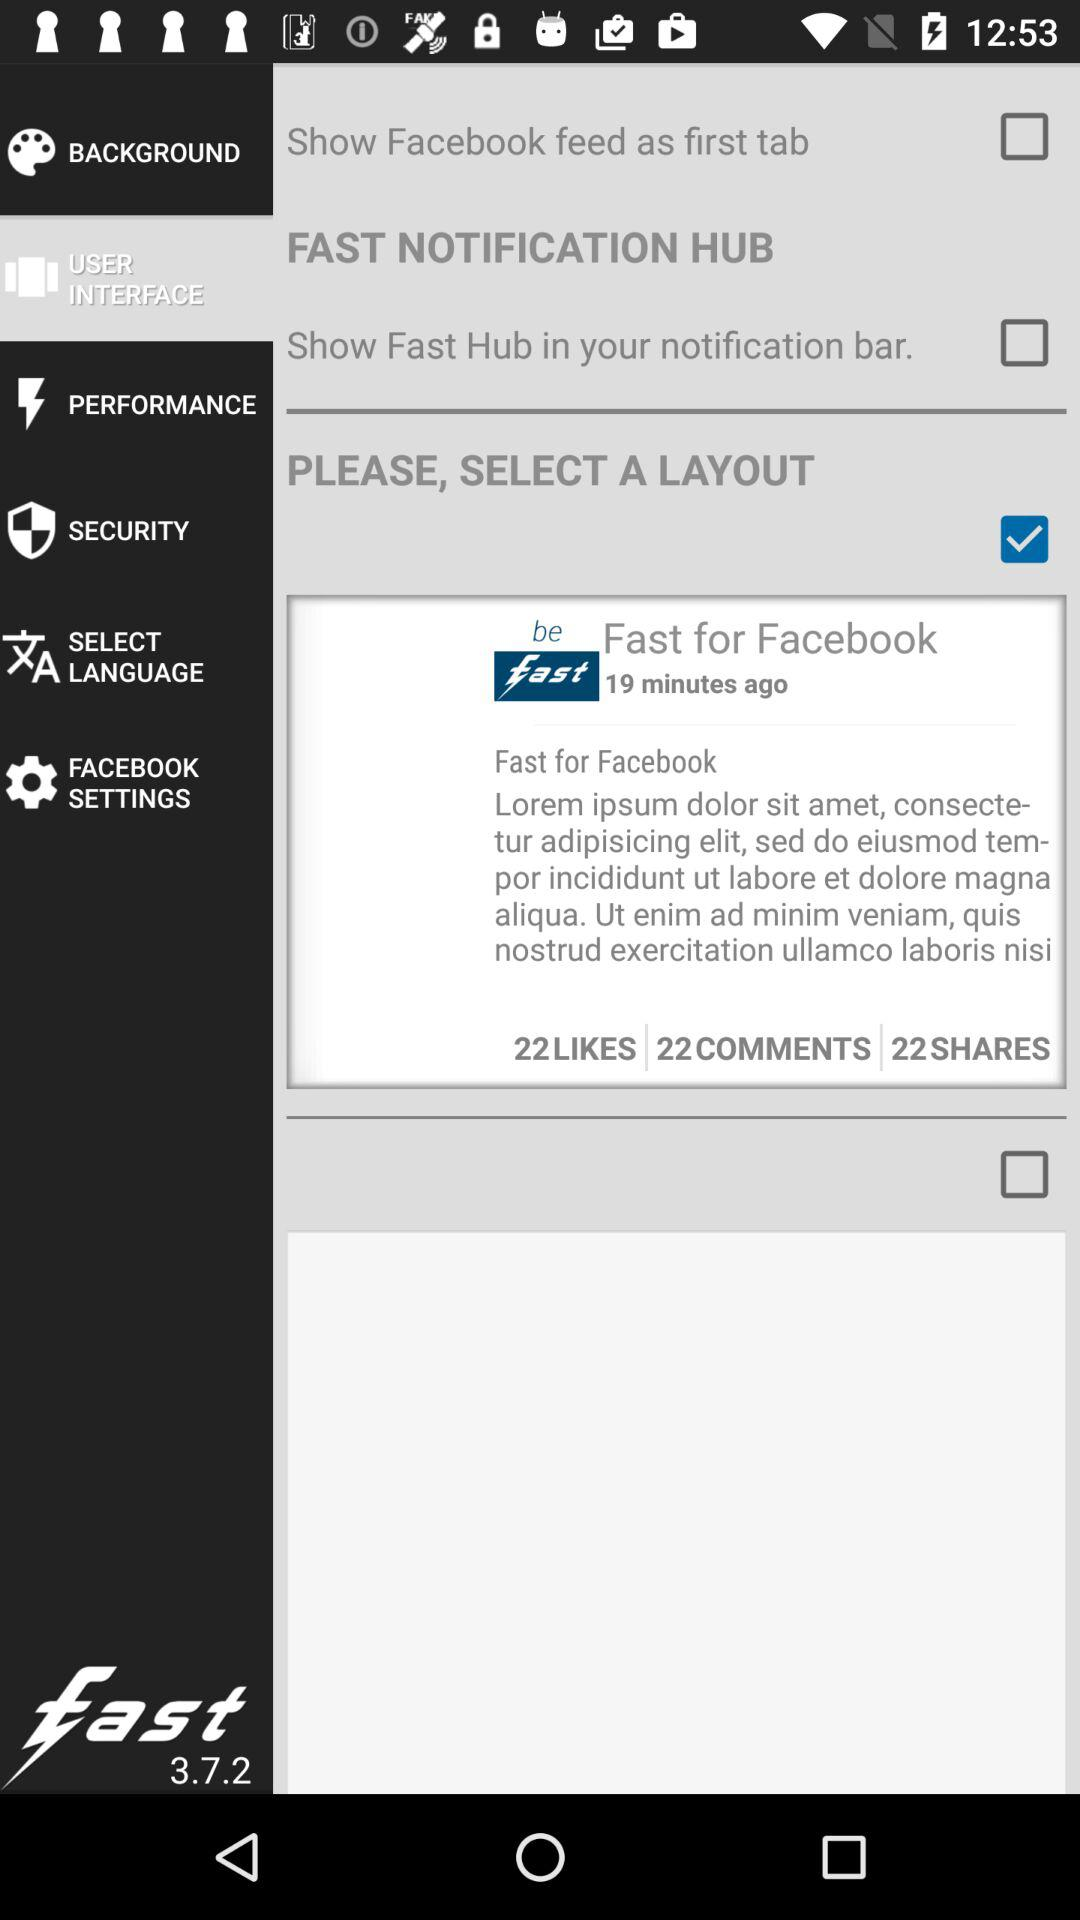Which option has been selected? The selected options are "USER INTERFACE" and "Fast for Facebook". 